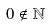<formula> <loc_0><loc_0><loc_500><loc_500>0 \notin \mathbb { N }</formula> 